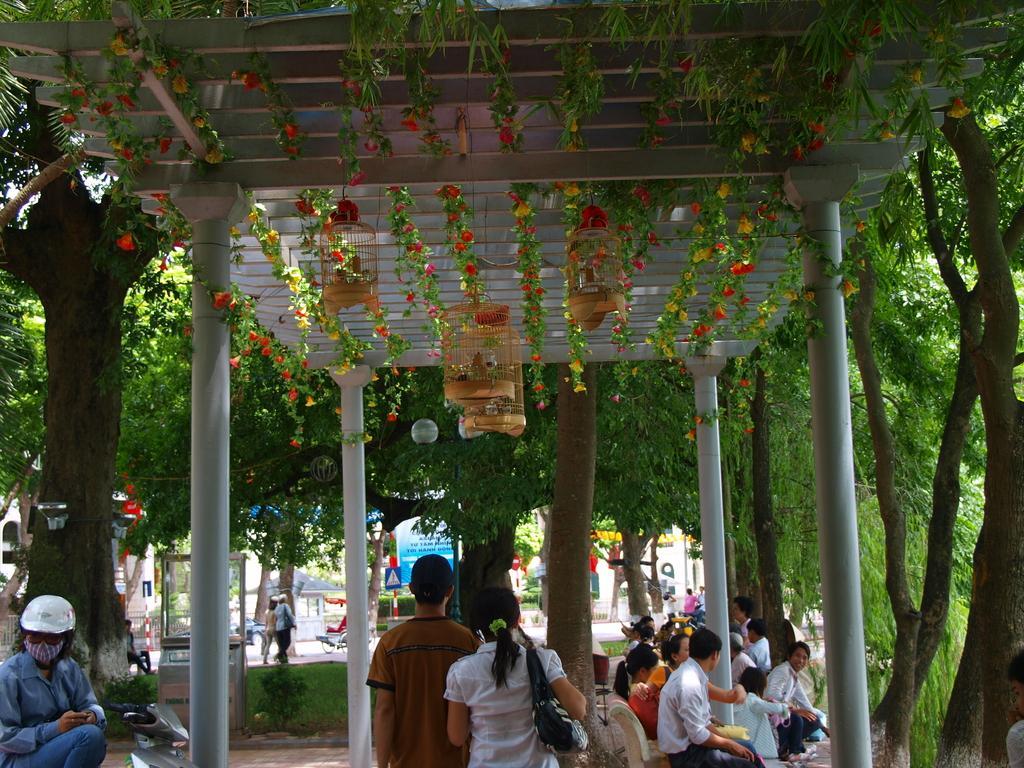Could you give a brief overview of what you see in this image? In this picture we can see cages, flowers, pillars, trees and a group of people where some are sitting on chairs and some are walking on the road and in the background we can see signboards, banner. 